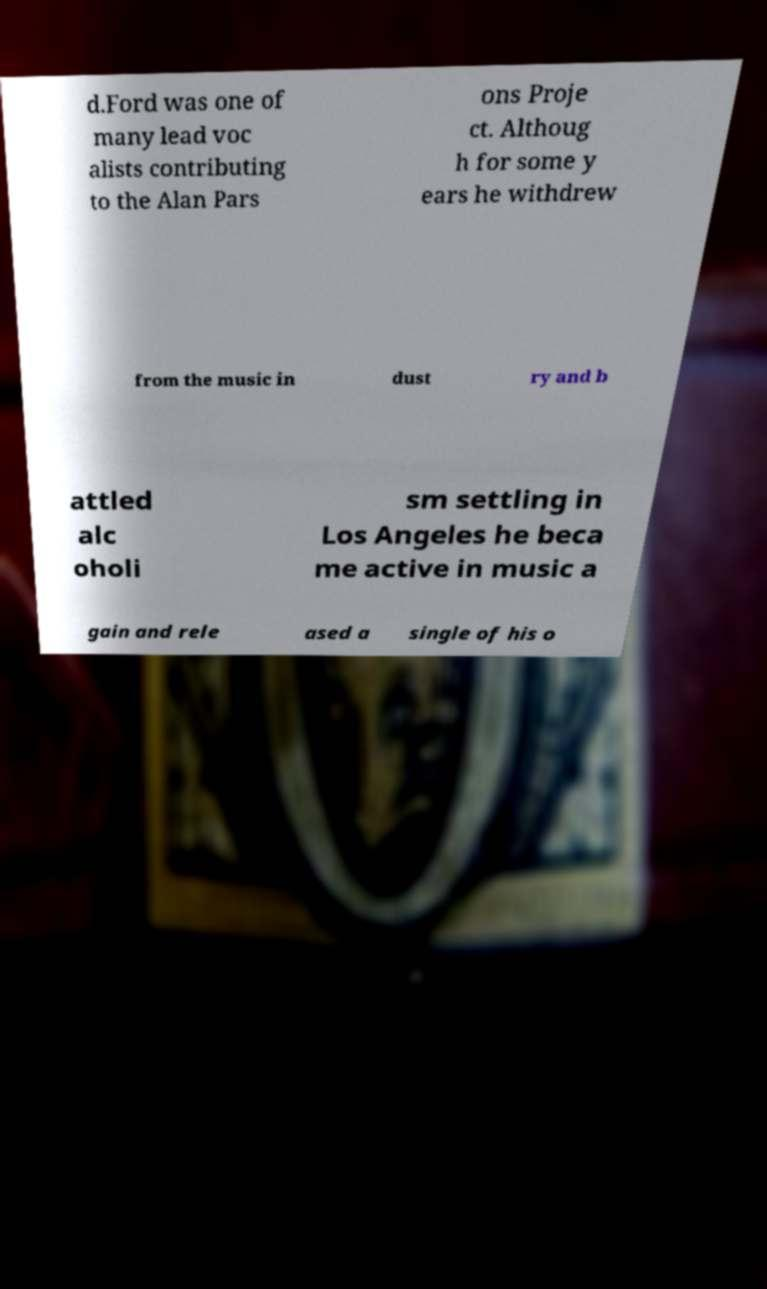Could you assist in decoding the text presented in this image and type it out clearly? d.Ford was one of many lead voc alists contributing to the Alan Pars ons Proje ct. Althoug h for some y ears he withdrew from the music in dust ry and b attled alc oholi sm settling in Los Angeles he beca me active in music a gain and rele ased a single of his o 